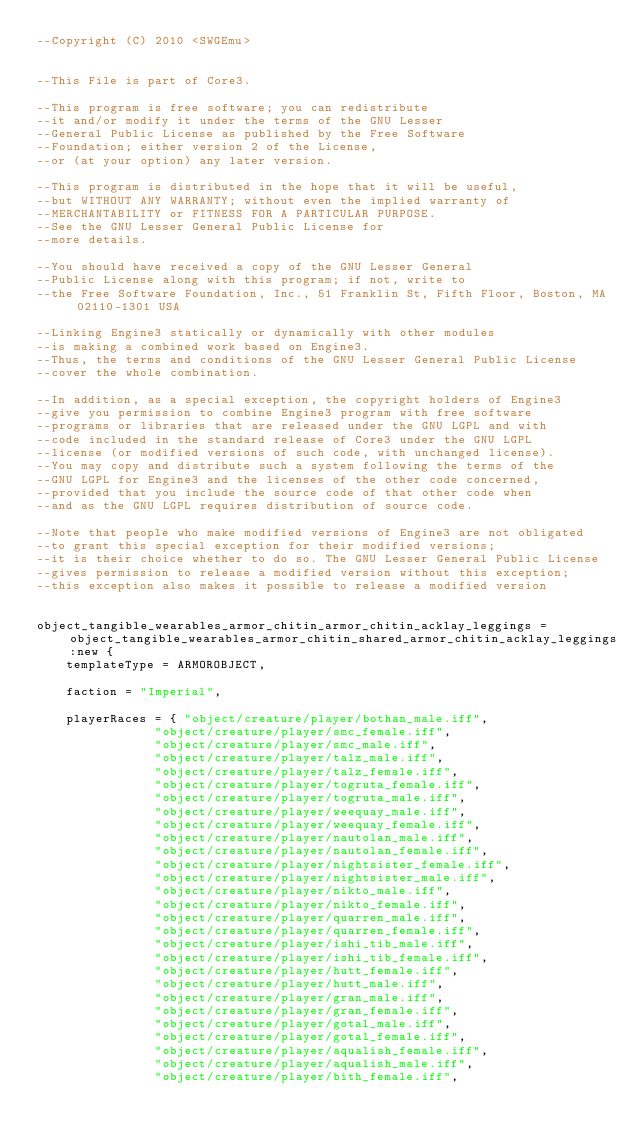<code> <loc_0><loc_0><loc_500><loc_500><_Lua_>--Copyright (C) 2010 <SWGEmu>


--This File is part of Core3.

--This program is free software; you can redistribute 
--it and/or modify it under the terms of the GNU Lesser 
--General Public License as published by the Free Software
--Foundation; either version 2 of the License, 
--or (at your option) any later version.

--This program is distributed in the hope that it will be useful, 
--but WITHOUT ANY WARRANTY; without even the implied warranty of 
--MERCHANTABILITY or FITNESS FOR A PARTICULAR PURPOSE. 
--See the GNU Lesser General Public License for
--more details.

--You should have received a copy of the GNU Lesser General 
--Public License along with this program; if not, write to
--the Free Software Foundation, Inc., 51 Franklin St, Fifth Floor, Boston, MA 02110-1301 USA

--Linking Engine3 statically or dynamically with other modules 
--is making a combined work based on Engine3. 
--Thus, the terms and conditions of the GNU Lesser General Public License 
--cover the whole combination.

--In addition, as a special exception, the copyright holders of Engine3 
--give you permission to combine Engine3 program with free software 
--programs or libraries that are released under the GNU LGPL and with 
--code included in the standard release of Core3 under the GNU LGPL 
--license (or modified versions of such code, with unchanged license). 
--You may copy and distribute such a system following the terms of the 
--GNU LGPL for Engine3 and the licenses of the other code concerned, 
--provided that you include the source code of that other code when 
--and as the GNU LGPL requires distribution of source code.

--Note that people who make modified versions of Engine3 are not obligated 
--to grant this special exception for their modified versions; 
--it is their choice whether to do so. The GNU Lesser General Public License 
--gives permission to release a modified version without this exception; 
--this exception also makes it possible to release a modified version 


object_tangible_wearables_armor_chitin_armor_chitin_acklay_leggings = object_tangible_wearables_armor_chitin_shared_armor_chitin_acklay_leggings:new {
	templateType = ARMOROBJECT,

	faction = "Imperial",

	playerRaces = { "object/creature/player/bothan_male.iff",
				"object/creature/player/smc_female.iff",
				"object/creature/player/smc_male.iff",
				"object/creature/player/talz_male.iff",
				"object/creature/player/talz_female.iff",
				"object/creature/player/togruta_female.iff",
				"object/creature/player/togruta_male.iff",
				"object/creature/player/weequay_male.iff",
				"object/creature/player/weequay_female.iff",
				"object/creature/player/nautolan_male.iff",
				"object/creature/player/nautolan_female.iff",
				"object/creature/player/nightsister_female.iff",
				"object/creature/player/nightsister_male.iff",
				"object/creature/player/nikto_male.iff",
				"object/creature/player/nikto_female.iff",
				"object/creature/player/quarren_male.iff",
				"object/creature/player/quarren_female.iff",
				"object/creature/player/ishi_tib_male.iff",
				"object/creature/player/ishi_tib_female.iff",
				"object/creature/player/hutt_female.iff",
				"object/creature/player/hutt_male.iff",
				"object/creature/player/gran_male.iff",
				"object/creature/player/gran_female.iff",
				"object/creature/player/gotal_male.iff",
				"object/creature/player/gotal_female.iff",
				"object/creature/player/aqualish_female.iff",
				"object/creature/player/aqualish_male.iff",
				"object/creature/player/bith_female.iff",</code> 